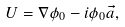Convert formula to latex. <formula><loc_0><loc_0><loc_500><loc_500>U = \nabla \phi _ { 0 } - i \phi _ { 0 } \vec { a } ,</formula> 